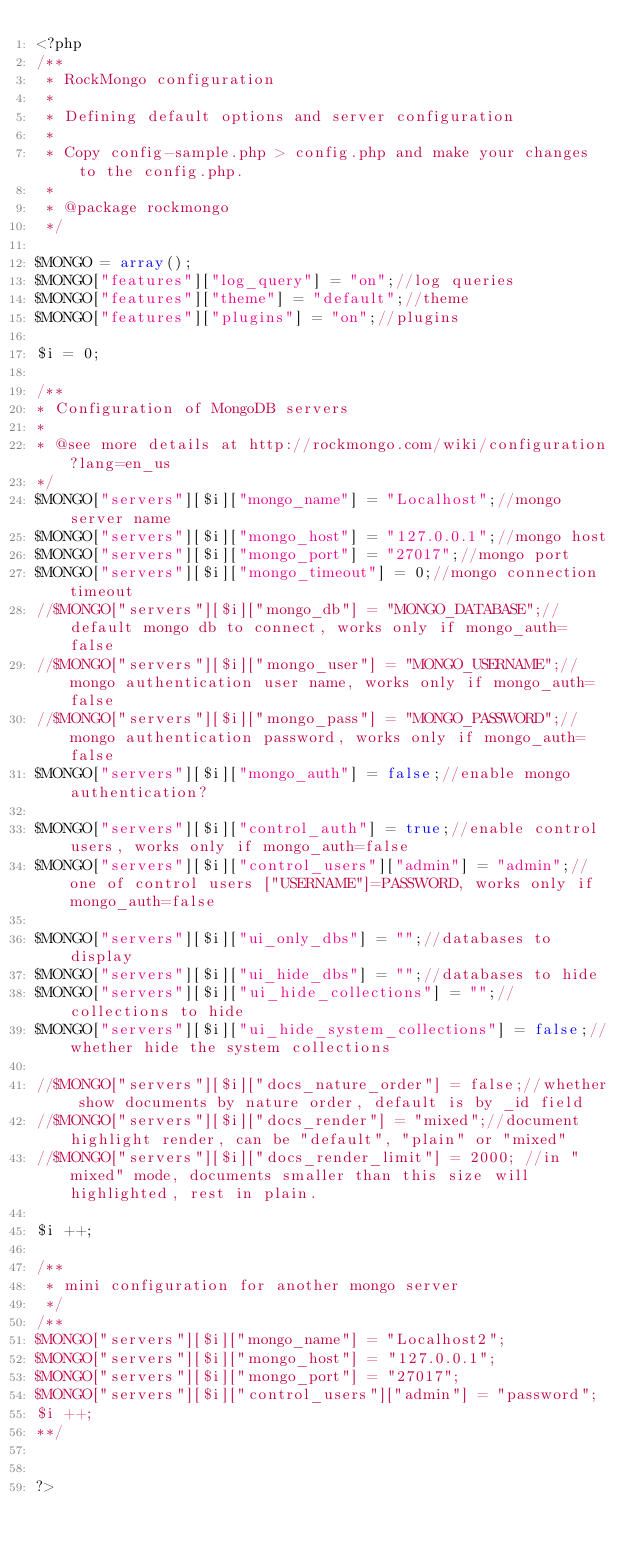Convert code to text. <code><loc_0><loc_0><loc_500><loc_500><_PHP_><?php
/**
 * RockMongo configuration
 *
 * Defining default options and server configuration
 *
 * Copy config-sample.php > config.php and make your changes to the config.php.
 *
 * @package rockmongo
 */
 
$MONGO = array();
$MONGO["features"]["log_query"] = "on";//log queries
$MONGO["features"]["theme"] = "default";//theme
$MONGO["features"]["plugins"] = "on";//plugins

$i = 0;

/**
* Configuration of MongoDB servers
* 
* @see more details at http://rockmongo.com/wiki/configuration?lang=en_us
*/
$MONGO["servers"][$i]["mongo_name"] = "Localhost";//mongo server name
$MONGO["servers"][$i]["mongo_host"] = "127.0.0.1";//mongo host
$MONGO["servers"][$i]["mongo_port"] = "27017";//mongo port
$MONGO["servers"][$i]["mongo_timeout"] = 0;//mongo connection timeout
//$MONGO["servers"][$i]["mongo_db"] = "MONGO_DATABASE";//default mongo db to connect, works only if mongo_auth=false
//$MONGO["servers"][$i]["mongo_user"] = "MONGO_USERNAME";//mongo authentication user name, works only if mongo_auth=false
//$MONGO["servers"][$i]["mongo_pass"] = "MONGO_PASSWORD";//mongo authentication password, works only if mongo_auth=false
$MONGO["servers"][$i]["mongo_auth"] = false;//enable mongo authentication?

$MONGO["servers"][$i]["control_auth"] = true;//enable control users, works only if mongo_auth=false
$MONGO["servers"][$i]["control_users"]["admin"] = "admin";//one of control users ["USERNAME"]=PASSWORD, works only if mongo_auth=false

$MONGO["servers"][$i]["ui_only_dbs"] = "";//databases to display
$MONGO["servers"][$i]["ui_hide_dbs"] = "";//databases to hide
$MONGO["servers"][$i]["ui_hide_collections"] = "";//collections to hide
$MONGO["servers"][$i]["ui_hide_system_collections"] = false;//whether hide the system collections

//$MONGO["servers"][$i]["docs_nature_order"] = false;//whether show documents by nature order, default is by _id field
//$MONGO["servers"][$i]["docs_render"] = "mixed";//document highlight render, can be "default", "plain" or "mixed"
//$MONGO["servers"][$i]["docs_render_limit"] = 2000; //in "mixed" mode, documents smaller than this size will highlighted, rest in plain.

$i ++;

/**
 * mini configuration for another mongo server
 */
/**
$MONGO["servers"][$i]["mongo_name"] = "Localhost2";
$MONGO["servers"][$i]["mongo_host"] = "127.0.0.1";
$MONGO["servers"][$i]["mongo_port"] = "27017";
$MONGO["servers"][$i]["control_users"]["admin"] = "password";
$i ++;
**/


?>
</code> 